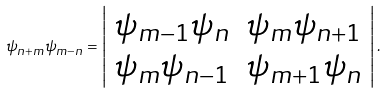Convert formula to latex. <formula><loc_0><loc_0><loc_500><loc_500>\psi _ { n + m } \psi _ { m - n } = \left | \begin{array} { r r } \psi _ { m - 1 } \psi _ { n } & \psi _ { m } \psi _ { n + 1 } \\ \psi _ { m } \psi _ { n - 1 } & \psi _ { m + 1 } \psi _ { n } \end{array} \right | .</formula> 